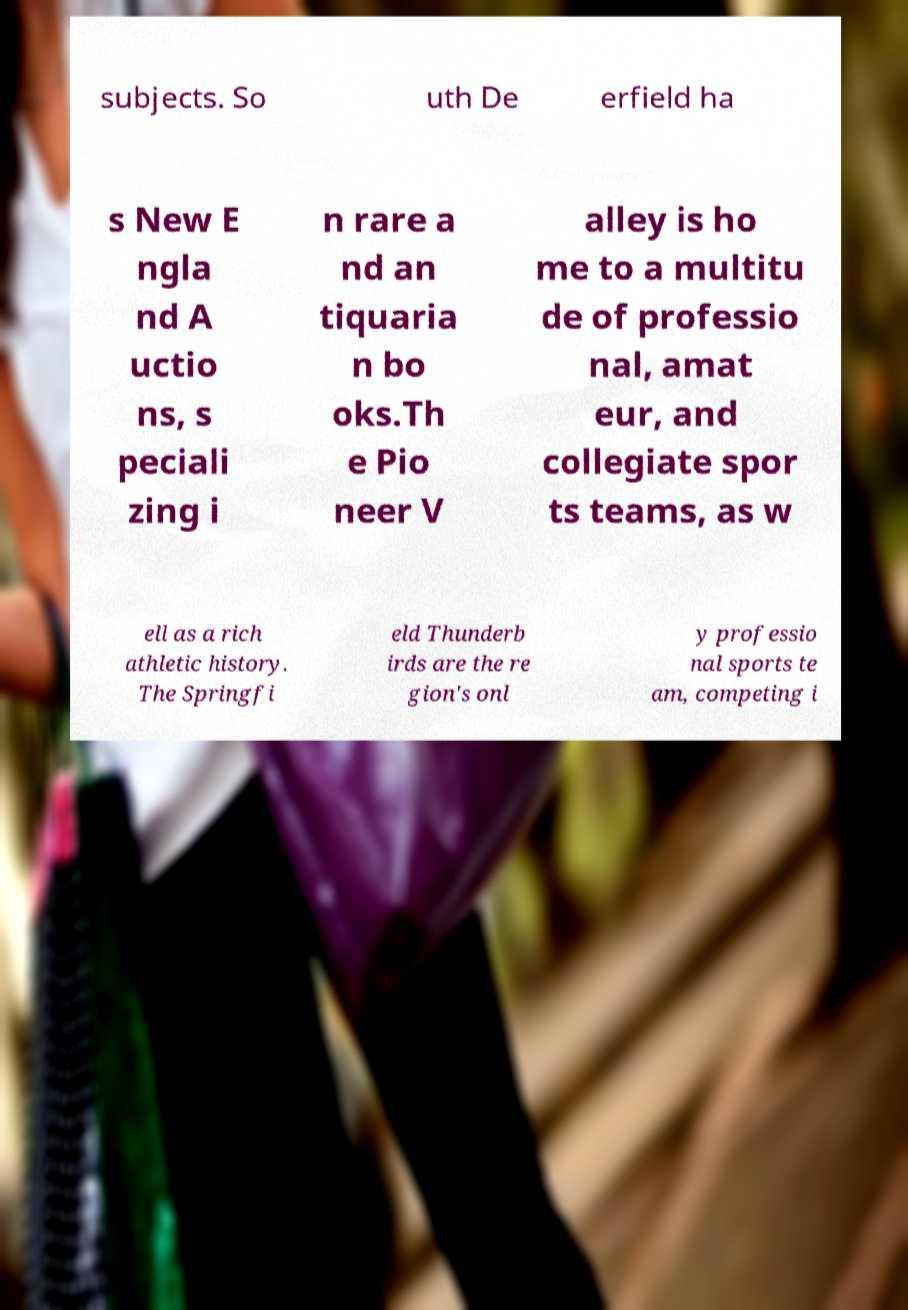I need the written content from this picture converted into text. Can you do that? subjects. So uth De erfield ha s New E ngla nd A uctio ns, s peciali zing i n rare a nd an tiquaria n bo oks.Th e Pio neer V alley is ho me to a multitu de of professio nal, amat eur, and collegiate spor ts teams, as w ell as a rich athletic history. The Springfi eld Thunderb irds are the re gion's onl y professio nal sports te am, competing i 